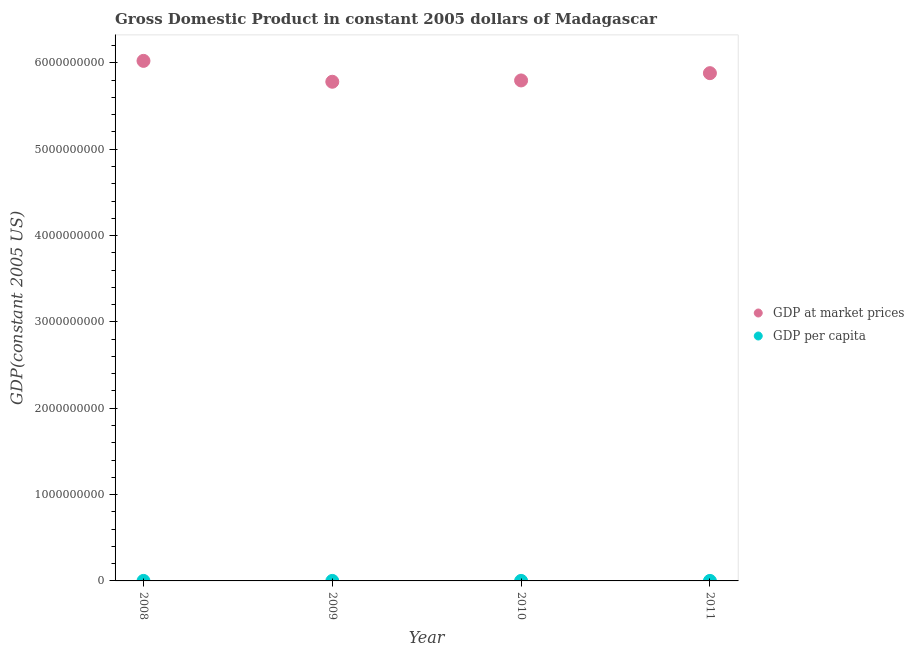How many different coloured dotlines are there?
Keep it short and to the point. 2. Is the number of dotlines equal to the number of legend labels?
Your answer should be compact. Yes. What is the gdp per capita in 2011?
Your answer should be compact. 271.29. Across all years, what is the maximum gdp at market prices?
Ensure brevity in your answer.  6.02e+09. Across all years, what is the minimum gdp per capita?
Offer a very short reply. 271.29. In which year was the gdp per capita minimum?
Your answer should be very brief. 2011. What is the total gdp at market prices in the graph?
Offer a very short reply. 2.35e+1. What is the difference between the gdp per capita in 2009 and that in 2010?
Your response must be concise. 7.09. What is the difference between the gdp per capita in 2010 and the gdp at market prices in 2009?
Make the answer very short. -5.78e+09. What is the average gdp at market prices per year?
Offer a very short reply. 5.87e+09. In the year 2009, what is the difference between the gdp per capita and gdp at market prices?
Provide a succinct answer. -5.78e+09. In how many years, is the gdp at market prices greater than 4400000000 US$?
Your answer should be compact. 4. What is the ratio of the gdp at market prices in 2009 to that in 2011?
Offer a terse response. 0.98. Is the difference between the gdp per capita in 2009 and 2010 greater than the difference between the gdp at market prices in 2009 and 2010?
Your answer should be compact. Yes. What is the difference between the highest and the second highest gdp at market prices?
Ensure brevity in your answer.  1.42e+08. What is the difference between the highest and the lowest gdp at market prices?
Ensure brevity in your answer.  2.42e+08. Is the sum of the gdp per capita in 2010 and 2011 greater than the maximum gdp at market prices across all years?
Ensure brevity in your answer.  No. Does the gdp at market prices monotonically increase over the years?
Your answer should be compact. No. Is the gdp at market prices strictly greater than the gdp per capita over the years?
Offer a very short reply. Yes. How many dotlines are there?
Give a very brief answer. 2. Are the values on the major ticks of Y-axis written in scientific E-notation?
Make the answer very short. No. Does the graph contain any zero values?
Your response must be concise. No. What is the title of the graph?
Your answer should be very brief. Gross Domestic Product in constant 2005 dollars of Madagascar. What is the label or title of the X-axis?
Your answer should be very brief. Year. What is the label or title of the Y-axis?
Give a very brief answer. GDP(constant 2005 US). What is the GDP(constant 2005 US) of GDP at market prices in 2008?
Ensure brevity in your answer.  6.02e+09. What is the GDP(constant 2005 US) in GDP per capita in 2008?
Offer a terse response. 302.28. What is the GDP(constant 2005 US) of GDP at market prices in 2009?
Give a very brief answer. 5.78e+09. What is the GDP(constant 2005 US) of GDP per capita in 2009?
Give a very brief answer. 282.09. What is the GDP(constant 2005 US) of GDP at market prices in 2010?
Your answer should be compact. 5.80e+09. What is the GDP(constant 2005 US) of GDP per capita in 2010?
Provide a succinct answer. 275. What is the GDP(constant 2005 US) of GDP at market prices in 2011?
Provide a succinct answer. 5.88e+09. What is the GDP(constant 2005 US) of GDP per capita in 2011?
Make the answer very short. 271.29. Across all years, what is the maximum GDP(constant 2005 US) of GDP at market prices?
Your response must be concise. 6.02e+09. Across all years, what is the maximum GDP(constant 2005 US) in GDP per capita?
Offer a terse response. 302.28. Across all years, what is the minimum GDP(constant 2005 US) in GDP at market prices?
Keep it short and to the point. 5.78e+09. Across all years, what is the minimum GDP(constant 2005 US) of GDP per capita?
Your answer should be very brief. 271.29. What is the total GDP(constant 2005 US) of GDP at market prices in the graph?
Your answer should be very brief. 2.35e+1. What is the total GDP(constant 2005 US) of GDP per capita in the graph?
Your response must be concise. 1130.67. What is the difference between the GDP(constant 2005 US) in GDP at market prices in 2008 and that in 2009?
Keep it short and to the point. 2.42e+08. What is the difference between the GDP(constant 2005 US) in GDP per capita in 2008 and that in 2009?
Your answer should be very brief. 20.19. What is the difference between the GDP(constant 2005 US) in GDP at market prices in 2008 and that in 2010?
Ensure brevity in your answer.  2.27e+08. What is the difference between the GDP(constant 2005 US) of GDP per capita in 2008 and that in 2010?
Your answer should be very brief. 27.28. What is the difference between the GDP(constant 2005 US) in GDP at market prices in 2008 and that in 2011?
Your response must be concise. 1.42e+08. What is the difference between the GDP(constant 2005 US) of GDP per capita in 2008 and that in 2011?
Your answer should be compact. 30.99. What is the difference between the GDP(constant 2005 US) in GDP at market prices in 2009 and that in 2010?
Offer a terse response. -1.52e+07. What is the difference between the GDP(constant 2005 US) in GDP per capita in 2009 and that in 2010?
Provide a short and direct response. 7.09. What is the difference between the GDP(constant 2005 US) in GDP at market prices in 2009 and that in 2011?
Offer a terse response. -9.95e+07. What is the difference between the GDP(constant 2005 US) in GDP per capita in 2009 and that in 2011?
Offer a very short reply. 10.8. What is the difference between the GDP(constant 2005 US) in GDP at market prices in 2010 and that in 2011?
Make the answer very short. -8.43e+07. What is the difference between the GDP(constant 2005 US) of GDP per capita in 2010 and that in 2011?
Your answer should be very brief. 3.71. What is the difference between the GDP(constant 2005 US) of GDP at market prices in 2008 and the GDP(constant 2005 US) of GDP per capita in 2009?
Your response must be concise. 6.02e+09. What is the difference between the GDP(constant 2005 US) of GDP at market prices in 2008 and the GDP(constant 2005 US) of GDP per capita in 2010?
Provide a short and direct response. 6.02e+09. What is the difference between the GDP(constant 2005 US) in GDP at market prices in 2008 and the GDP(constant 2005 US) in GDP per capita in 2011?
Keep it short and to the point. 6.02e+09. What is the difference between the GDP(constant 2005 US) in GDP at market prices in 2009 and the GDP(constant 2005 US) in GDP per capita in 2010?
Offer a terse response. 5.78e+09. What is the difference between the GDP(constant 2005 US) in GDP at market prices in 2009 and the GDP(constant 2005 US) in GDP per capita in 2011?
Offer a very short reply. 5.78e+09. What is the difference between the GDP(constant 2005 US) in GDP at market prices in 2010 and the GDP(constant 2005 US) in GDP per capita in 2011?
Offer a very short reply. 5.80e+09. What is the average GDP(constant 2005 US) of GDP at market prices per year?
Provide a short and direct response. 5.87e+09. What is the average GDP(constant 2005 US) in GDP per capita per year?
Keep it short and to the point. 282.67. In the year 2008, what is the difference between the GDP(constant 2005 US) in GDP at market prices and GDP(constant 2005 US) in GDP per capita?
Offer a very short reply. 6.02e+09. In the year 2009, what is the difference between the GDP(constant 2005 US) in GDP at market prices and GDP(constant 2005 US) in GDP per capita?
Keep it short and to the point. 5.78e+09. In the year 2010, what is the difference between the GDP(constant 2005 US) of GDP at market prices and GDP(constant 2005 US) of GDP per capita?
Provide a succinct answer. 5.80e+09. In the year 2011, what is the difference between the GDP(constant 2005 US) in GDP at market prices and GDP(constant 2005 US) in GDP per capita?
Keep it short and to the point. 5.88e+09. What is the ratio of the GDP(constant 2005 US) of GDP at market prices in 2008 to that in 2009?
Provide a succinct answer. 1.04. What is the ratio of the GDP(constant 2005 US) in GDP per capita in 2008 to that in 2009?
Your answer should be very brief. 1.07. What is the ratio of the GDP(constant 2005 US) of GDP at market prices in 2008 to that in 2010?
Give a very brief answer. 1.04. What is the ratio of the GDP(constant 2005 US) of GDP per capita in 2008 to that in 2010?
Provide a succinct answer. 1.1. What is the ratio of the GDP(constant 2005 US) of GDP at market prices in 2008 to that in 2011?
Give a very brief answer. 1.02. What is the ratio of the GDP(constant 2005 US) in GDP per capita in 2008 to that in 2011?
Provide a succinct answer. 1.11. What is the ratio of the GDP(constant 2005 US) of GDP at market prices in 2009 to that in 2010?
Provide a short and direct response. 1. What is the ratio of the GDP(constant 2005 US) of GDP per capita in 2009 to that in 2010?
Offer a terse response. 1.03. What is the ratio of the GDP(constant 2005 US) in GDP at market prices in 2009 to that in 2011?
Provide a short and direct response. 0.98. What is the ratio of the GDP(constant 2005 US) in GDP per capita in 2009 to that in 2011?
Offer a very short reply. 1.04. What is the ratio of the GDP(constant 2005 US) of GDP at market prices in 2010 to that in 2011?
Ensure brevity in your answer.  0.99. What is the ratio of the GDP(constant 2005 US) of GDP per capita in 2010 to that in 2011?
Offer a very short reply. 1.01. What is the difference between the highest and the second highest GDP(constant 2005 US) of GDP at market prices?
Provide a succinct answer. 1.42e+08. What is the difference between the highest and the second highest GDP(constant 2005 US) in GDP per capita?
Offer a terse response. 20.19. What is the difference between the highest and the lowest GDP(constant 2005 US) in GDP at market prices?
Offer a very short reply. 2.42e+08. What is the difference between the highest and the lowest GDP(constant 2005 US) in GDP per capita?
Offer a terse response. 30.99. 